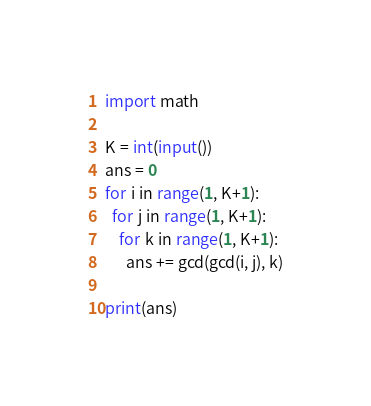Convert code to text. <code><loc_0><loc_0><loc_500><loc_500><_Python_>import math

K = int(input())
ans = 0
for i in range(1, K+1):
  for j in range(1, K+1):
    for k in range(1, K+1):
      ans += gcd(gcd(i, j), k)

print(ans)</code> 